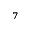<formula> <loc_0><loc_0><loc_500><loc_500>^ { 7 }</formula> 